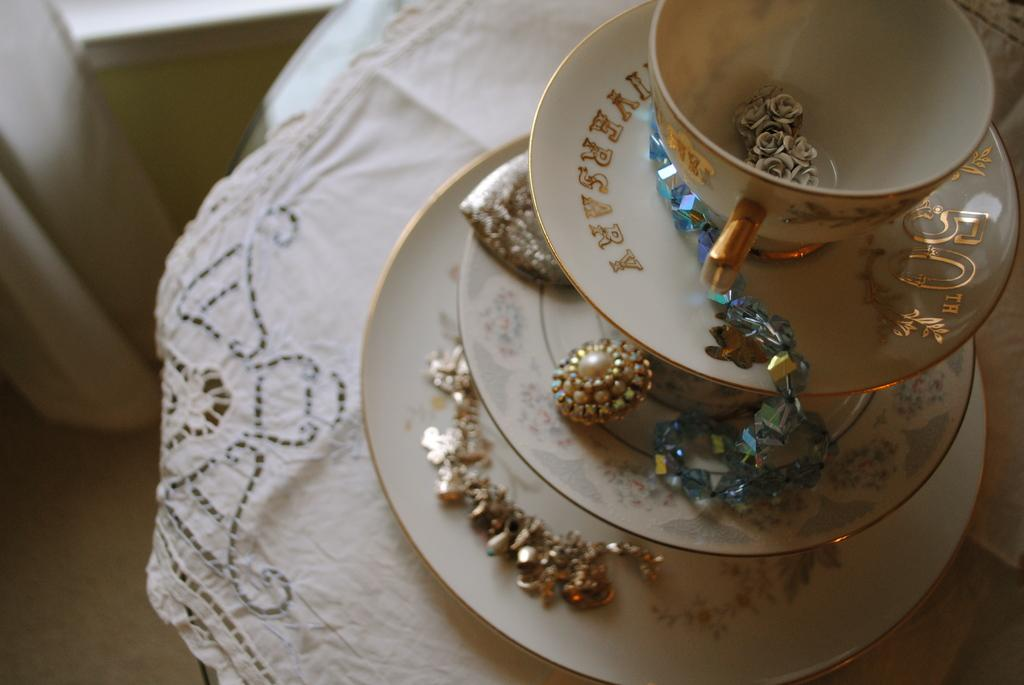What type of dishware can be seen in the image? There are saucers in the image. Is there anything placed on the saucers? Yes, there is a cup on one of the saucers, and there are colorful objects on the saucers. Where are the saucers and cup located? The saucers and cup are on a table. What type of basket is being used to carry the son to the trucks in the image? There is no basket, son, or trucks present in the image. 